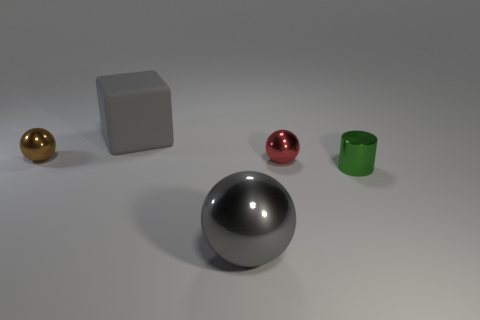There is a big thing that is the same color as the block; what material is it?
Offer a terse response. Metal. There is a big metal object that is the same color as the big block; what is its shape?
Ensure brevity in your answer.  Sphere. What is the size of the shiny object that is on the left side of the red object and behind the tiny green shiny object?
Provide a short and direct response. Small. What number of other objects are there of the same color as the small metallic cylinder?
Offer a very short reply. 0. Are there any other things that have the same shape as the red thing?
Ensure brevity in your answer.  Yes. Does the thing behind the tiny brown shiny sphere have the same color as the large shiny ball?
Ensure brevity in your answer.  Yes. There is a red metallic thing that is the same shape as the tiny brown object; what is its size?
Your response must be concise. Small. How many small yellow cubes have the same material as the red ball?
Offer a very short reply. 0. Is there a sphere that is in front of the tiny metal thing on the left side of the tiny sphere to the right of the tiny brown shiny object?
Your answer should be compact. Yes. What is the shape of the red shiny object?
Your answer should be very brief. Sphere. 